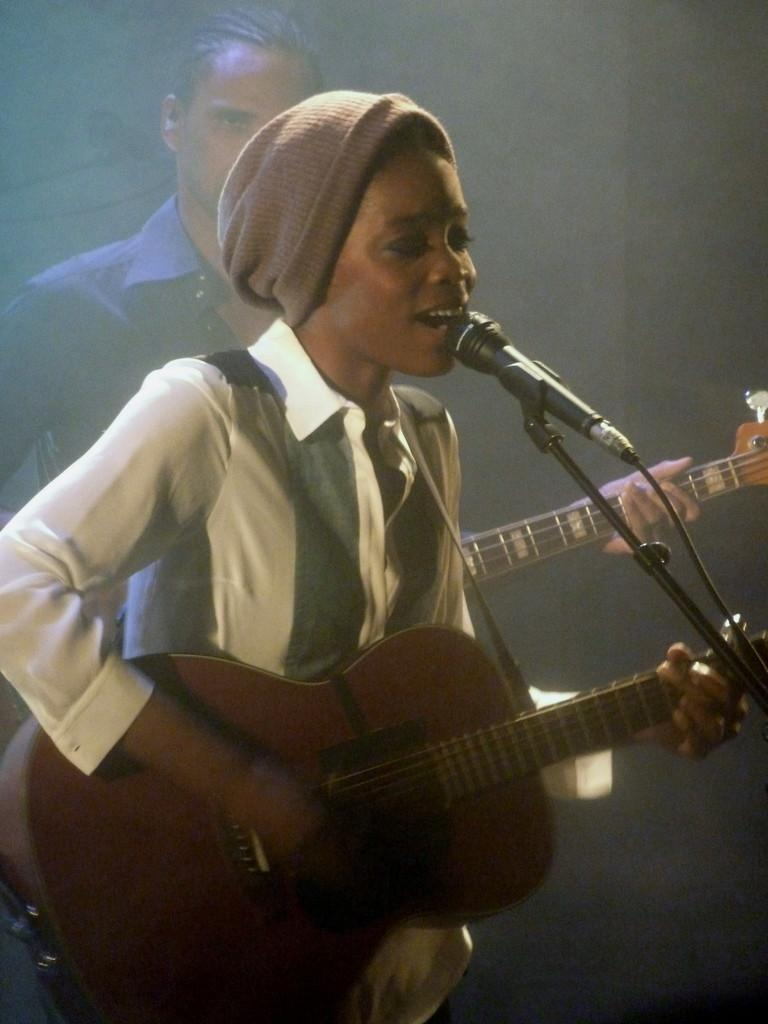How many people are in the image? There are two persons in the image. What are the persons doing in the image? One person is holding a microphone, and both persons are playing guitars. What is the other person doing besides playing the guitar? The other person is singing something. How many snails can be seen crawling on the guitar in the image? There are no snails present in the image; it features two persons playing guitars and singing. 